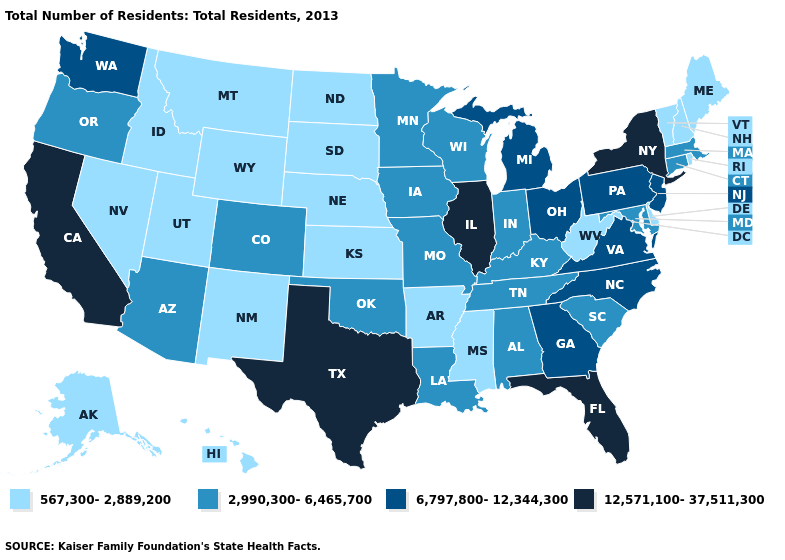Does the map have missing data?
Answer briefly. No. Among the states that border Pennsylvania , which have the lowest value?
Keep it brief. Delaware, West Virginia. Does Delaware have a lower value than Louisiana?
Write a very short answer. Yes. Which states hav the highest value in the West?
Answer briefly. California. Name the states that have a value in the range 6,797,800-12,344,300?
Keep it brief. Georgia, Michigan, New Jersey, North Carolina, Ohio, Pennsylvania, Virginia, Washington. Which states hav the highest value in the West?
Quick response, please. California. Name the states that have a value in the range 6,797,800-12,344,300?
Be succinct. Georgia, Michigan, New Jersey, North Carolina, Ohio, Pennsylvania, Virginia, Washington. Name the states that have a value in the range 2,990,300-6,465,700?
Short answer required. Alabama, Arizona, Colorado, Connecticut, Indiana, Iowa, Kentucky, Louisiana, Maryland, Massachusetts, Minnesota, Missouri, Oklahoma, Oregon, South Carolina, Tennessee, Wisconsin. What is the value of Mississippi?
Give a very brief answer. 567,300-2,889,200. Name the states that have a value in the range 6,797,800-12,344,300?
Keep it brief. Georgia, Michigan, New Jersey, North Carolina, Ohio, Pennsylvania, Virginia, Washington. Name the states that have a value in the range 567,300-2,889,200?
Give a very brief answer. Alaska, Arkansas, Delaware, Hawaii, Idaho, Kansas, Maine, Mississippi, Montana, Nebraska, Nevada, New Hampshire, New Mexico, North Dakota, Rhode Island, South Dakota, Utah, Vermont, West Virginia, Wyoming. What is the value of Rhode Island?
Answer briefly. 567,300-2,889,200. What is the highest value in states that border Maine?
Give a very brief answer. 567,300-2,889,200. Among the states that border Connecticut , does New York have the lowest value?
Short answer required. No. Is the legend a continuous bar?
Keep it brief. No. 